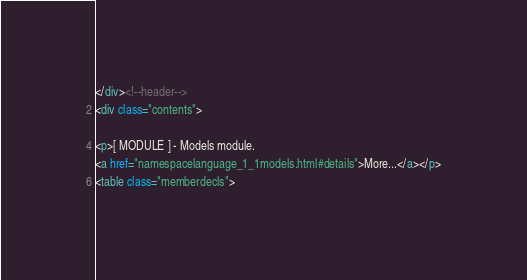<code> <loc_0><loc_0><loc_500><loc_500><_HTML_></div><!--header-->
<div class="contents">

<p>[ MODULE ] - Models module.  
<a href="namespacelanguage_1_1models.html#details">More...</a></p>
<table class="memberdecls"></code> 